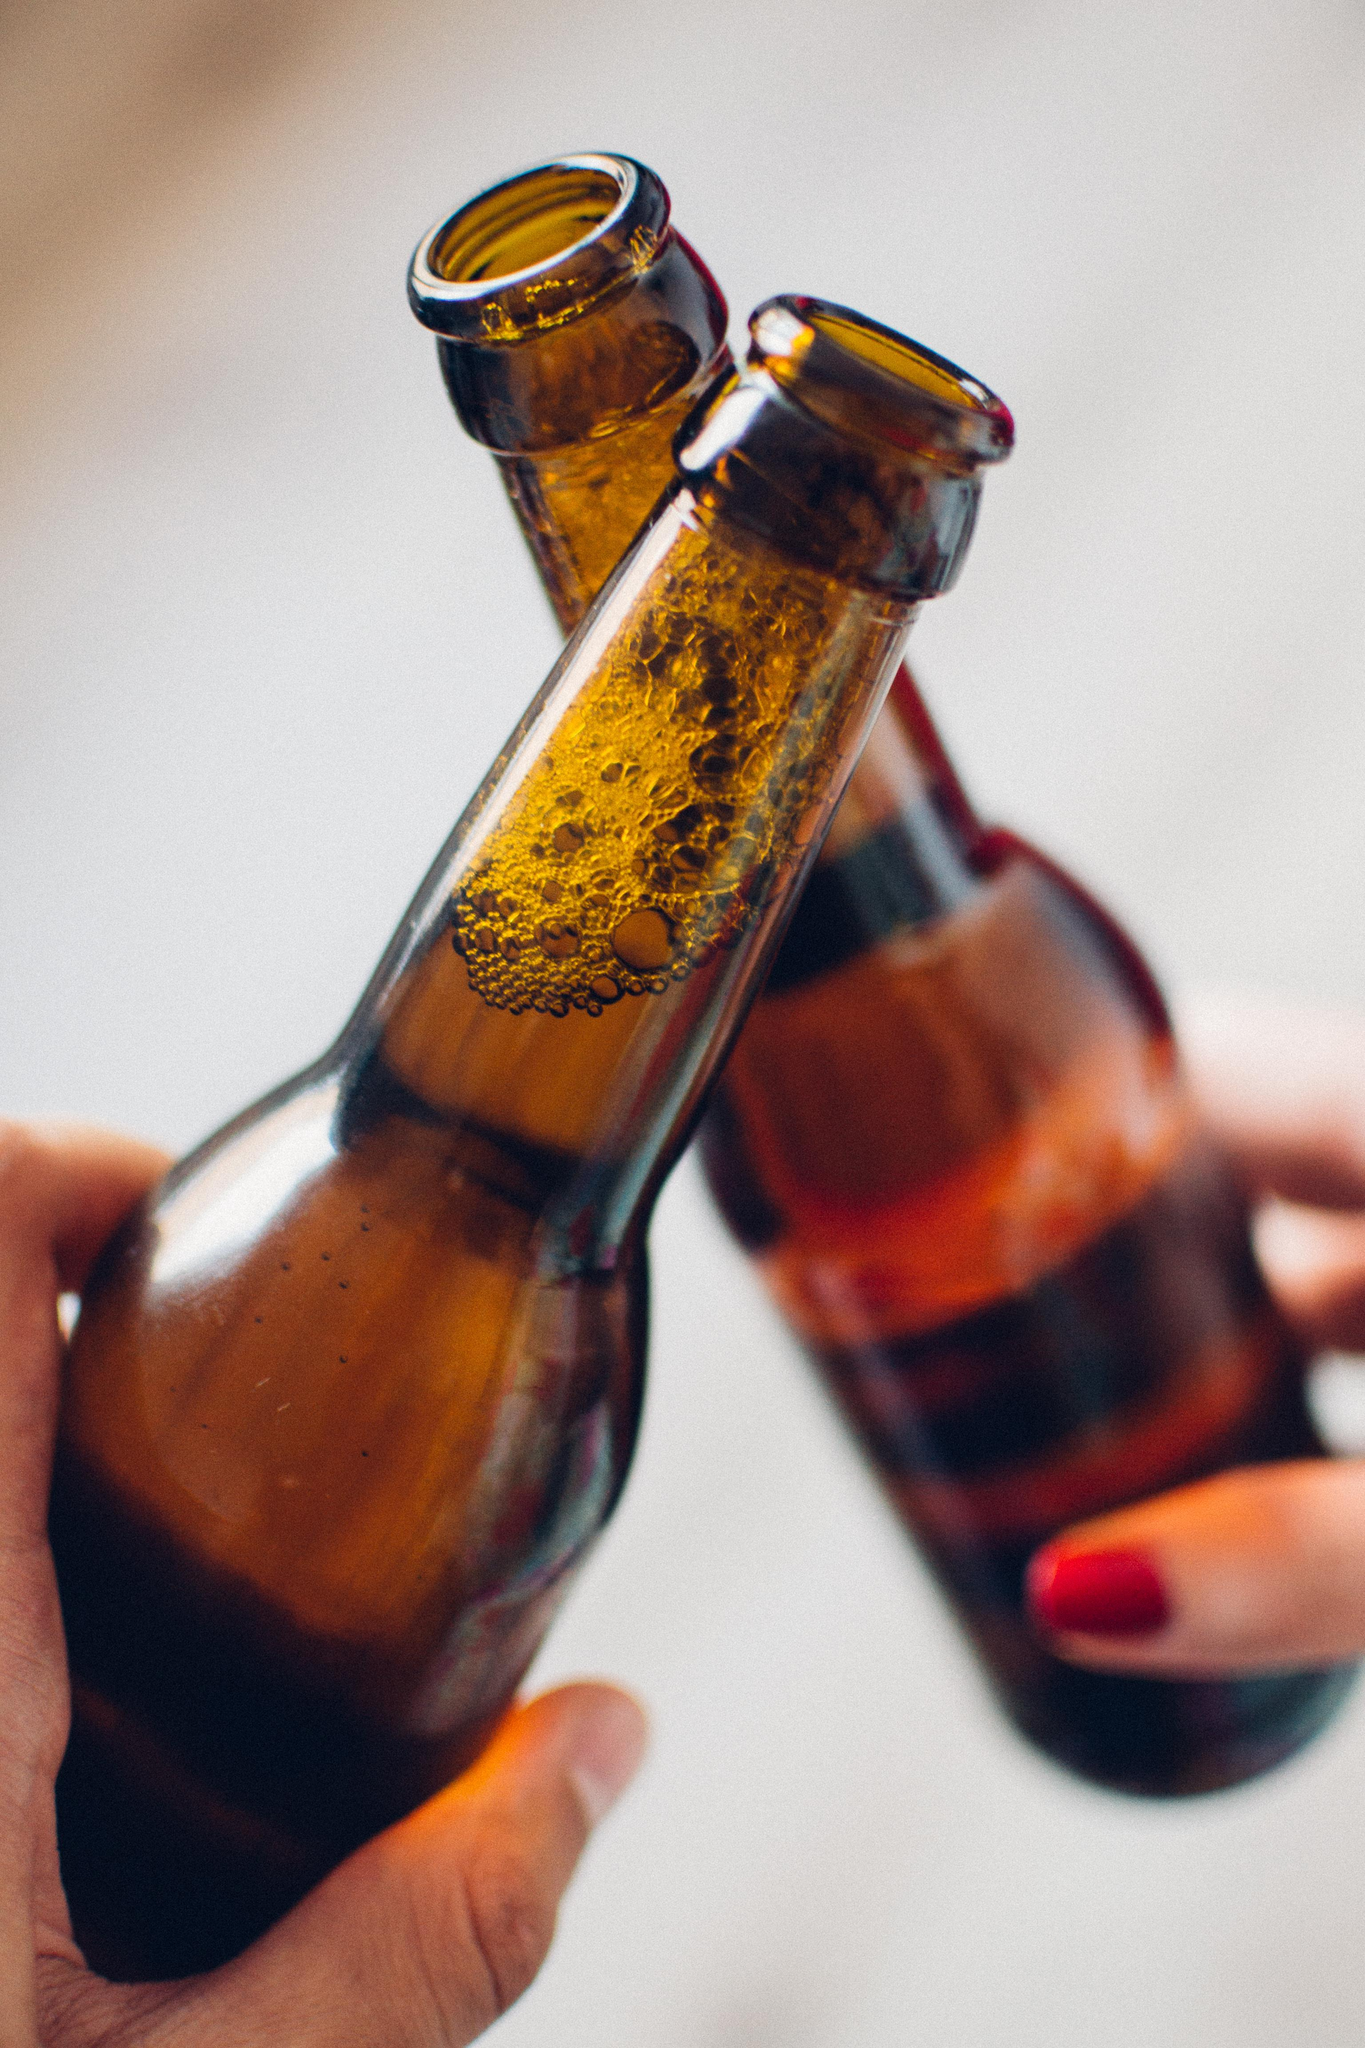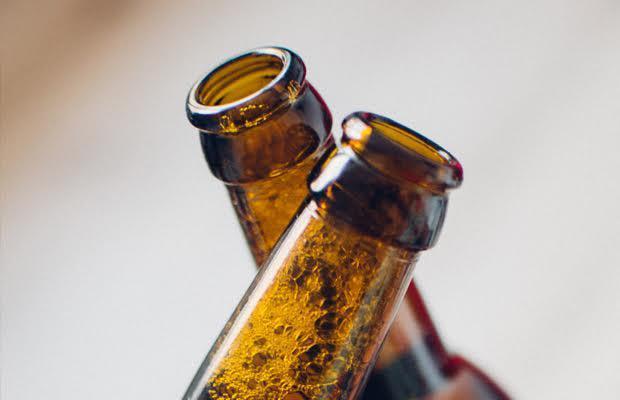The first image is the image on the left, the second image is the image on the right. Given the left and right images, does the statement "There are exactly four bottles being toasted, two in each image." hold true? Answer yes or no. Yes. 